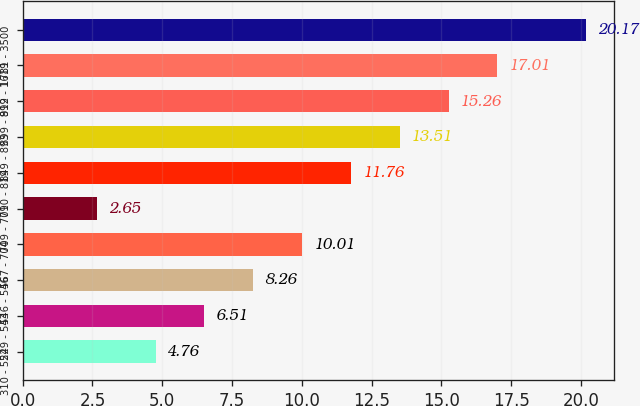Convert chart. <chart><loc_0><loc_0><loc_500><loc_500><bar_chart><fcel>310 - 524<fcel>529 - 543<fcel>546 - 546<fcel>567 - 704<fcel>709 - 709<fcel>710 - 819<fcel>849 - 893<fcel>899 - 899<fcel>912 - 1619<fcel>1781 - 3500<nl><fcel>4.76<fcel>6.51<fcel>8.26<fcel>10.01<fcel>2.65<fcel>11.76<fcel>13.51<fcel>15.26<fcel>17.01<fcel>20.17<nl></chart> 